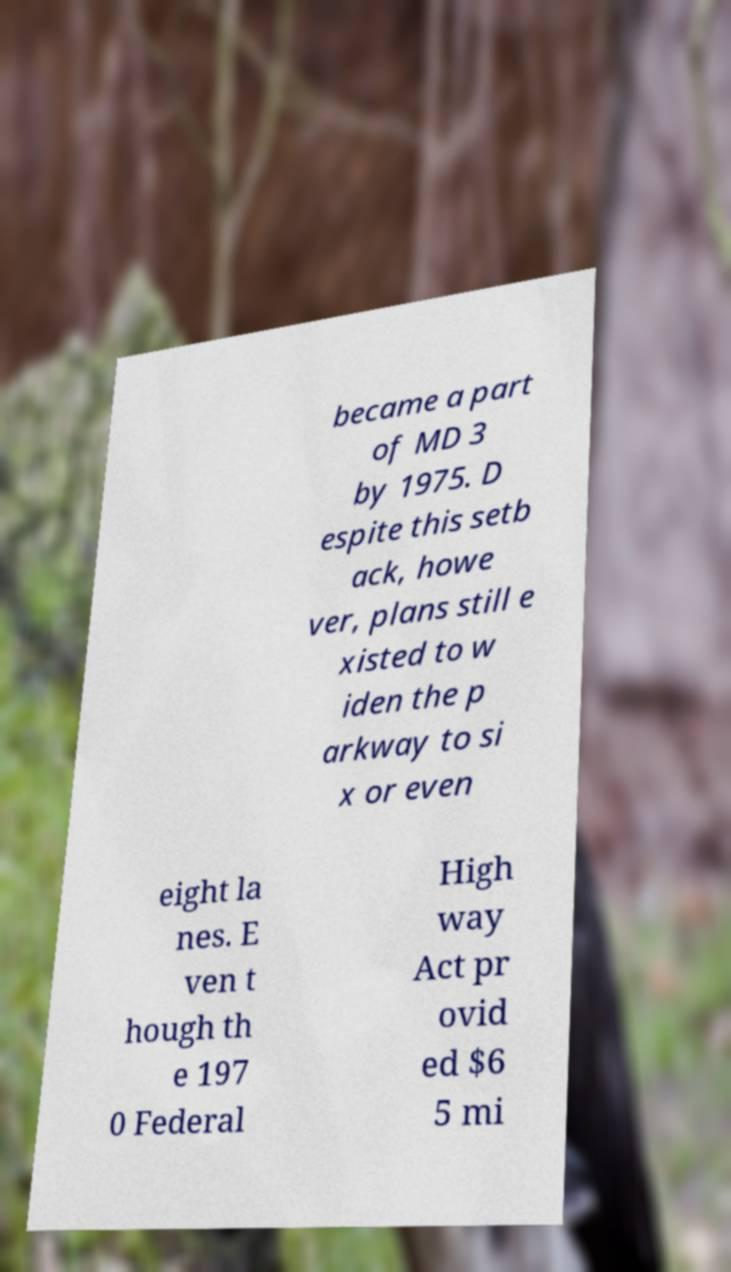Can you accurately transcribe the text from the provided image for me? became a part of MD 3 by 1975. D espite this setb ack, howe ver, plans still e xisted to w iden the p arkway to si x or even eight la nes. E ven t hough th e 197 0 Federal High way Act pr ovid ed $6 5 mi 